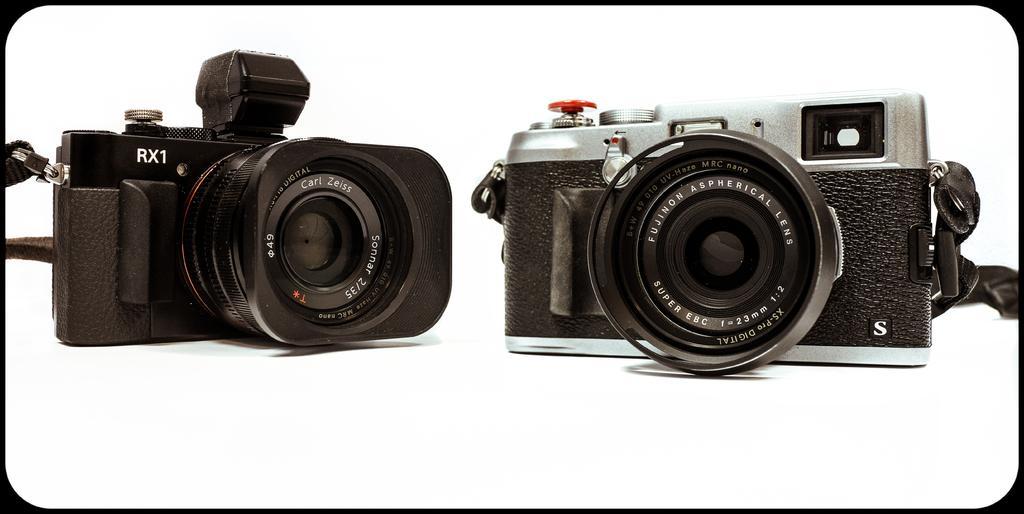Describe this image in one or two sentences. In the image we can see there are two cameras, these are the lenses, text and a white surface. 